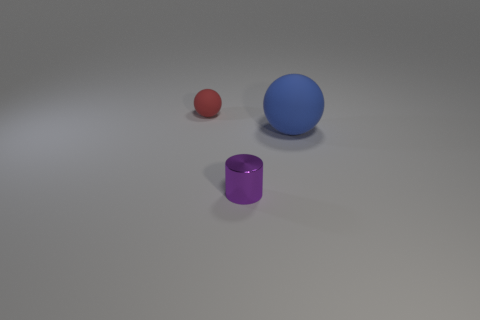Could you suggest what these objects might be used for? In a hypothetical context, the red sphere could be a small rubber ball for desk exercises, the blue sphere might be a decorative paperweight, and the purple cylinder could serve as a pen holder or a small container for office supplies. 